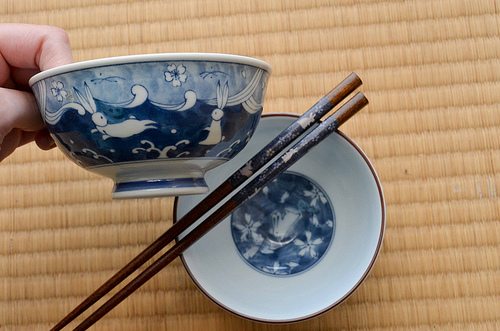<image>
Can you confirm if the bowl is on the bowl? Yes. Looking at the image, I can see the bowl is positioned on top of the bowl, with the bowl providing support. Where is the cup in relation to the saucer? Is it on the saucer? No. The cup is not positioned on the saucer. They may be near each other, but the cup is not supported by or resting on top of the saucer. 